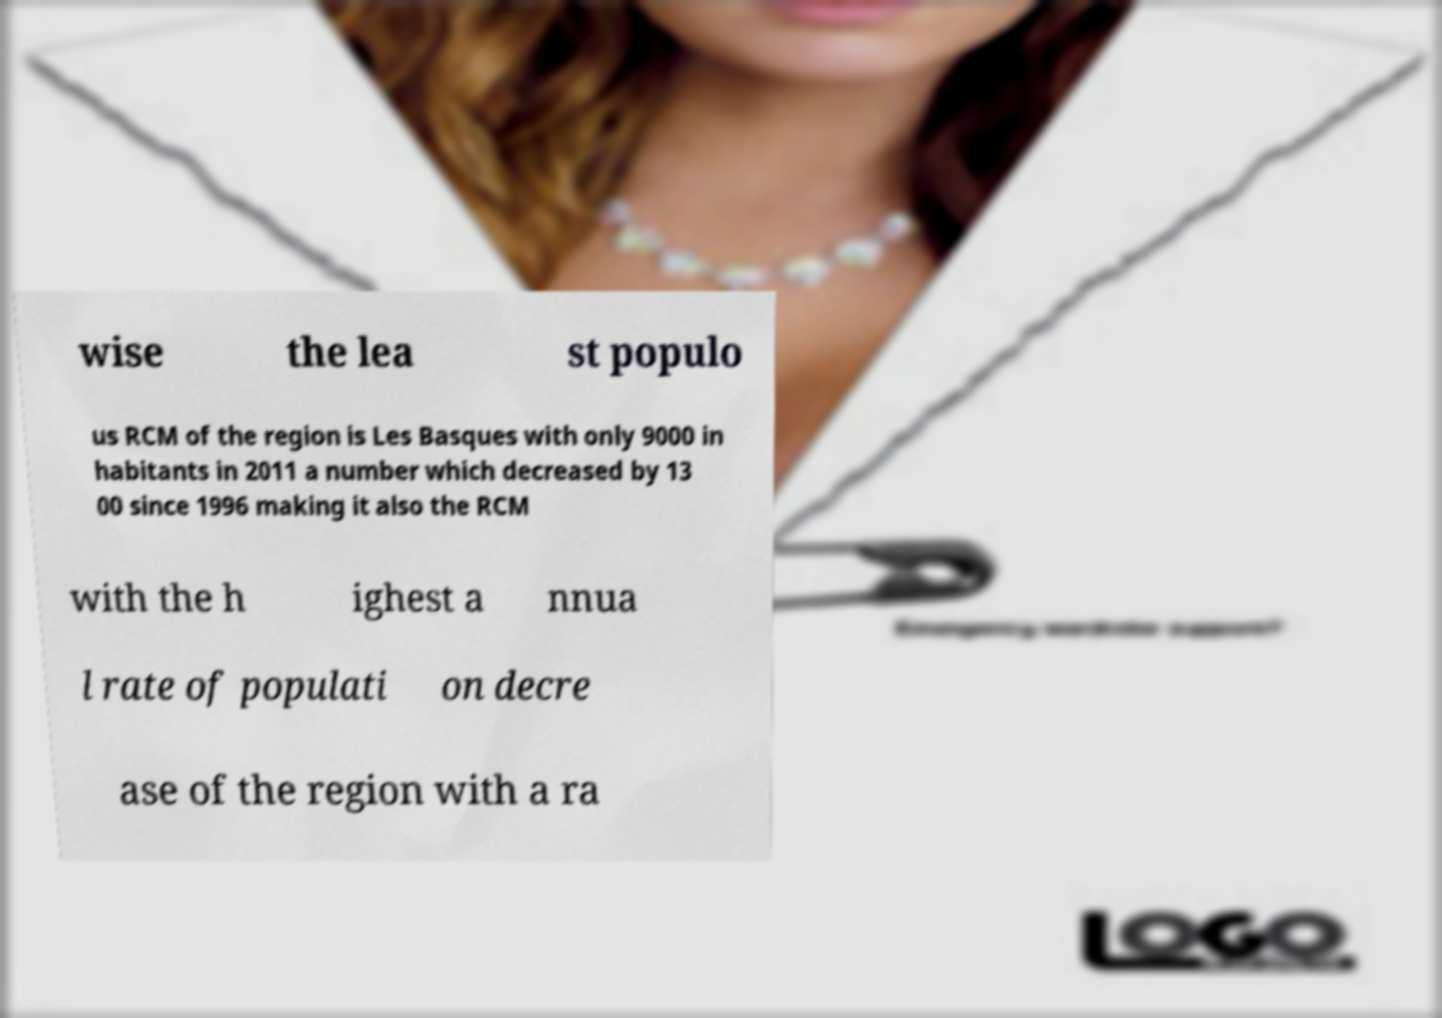Can you accurately transcribe the text from the provided image for me? wise the lea st populo us RCM of the region is Les Basques with only 9000 in habitants in 2011 a number which decreased by 13 00 since 1996 making it also the RCM with the h ighest a nnua l rate of populati on decre ase of the region with a ra 